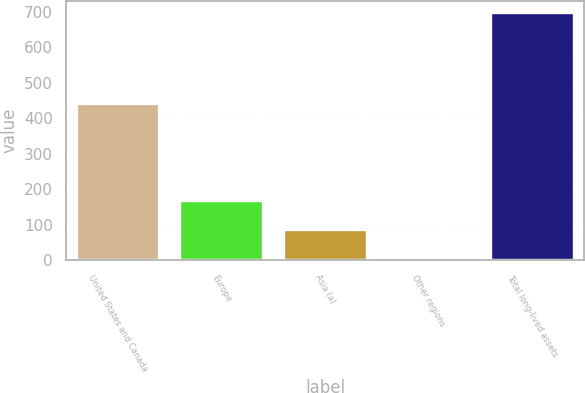Convert chart to OTSL. <chart><loc_0><loc_0><loc_500><loc_500><bar_chart><fcel>United States and Canada<fcel>Europe<fcel>Asia (a)<fcel>Other regions<fcel>Total long-lived assets<nl><fcel>441.6<fcel>166.4<fcel>84.1<fcel>5.1<fcel>697.2<nl></chart> 